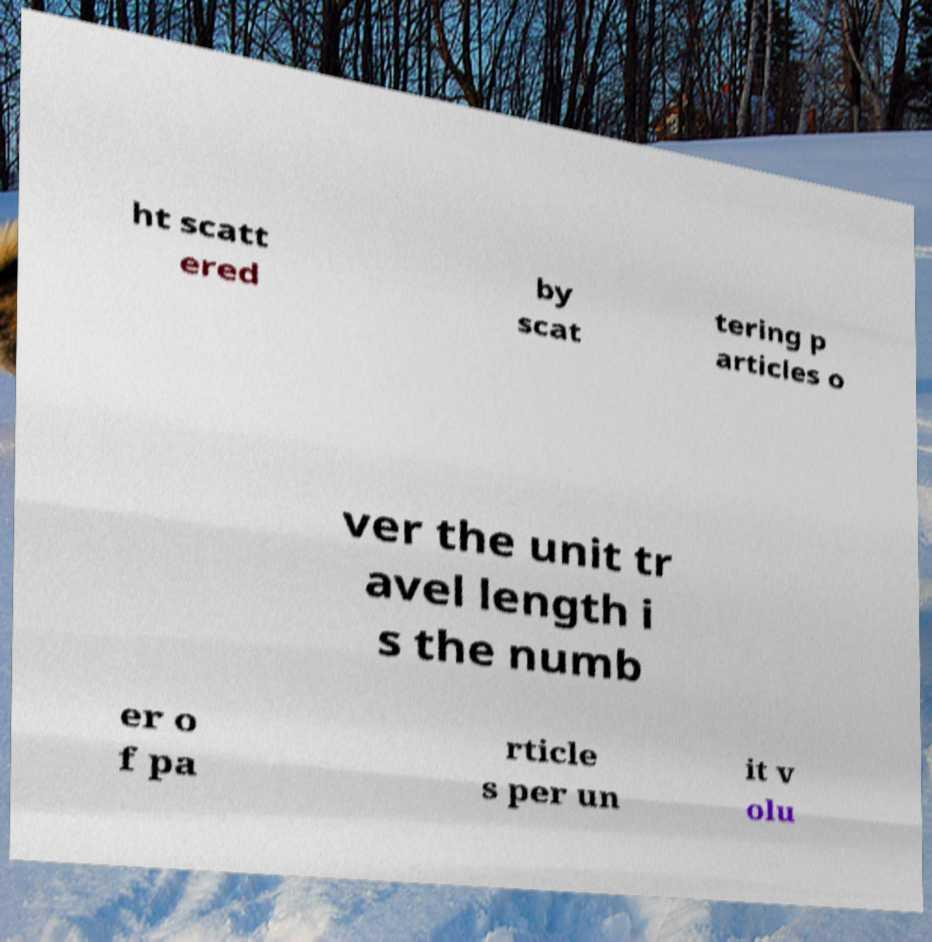Please read and relay the text visible in this image. What does it say? ht scatt ered by scat tering p articles o ver the unit tr avel length i s the numb er o f pa rticle s per un it v olu 